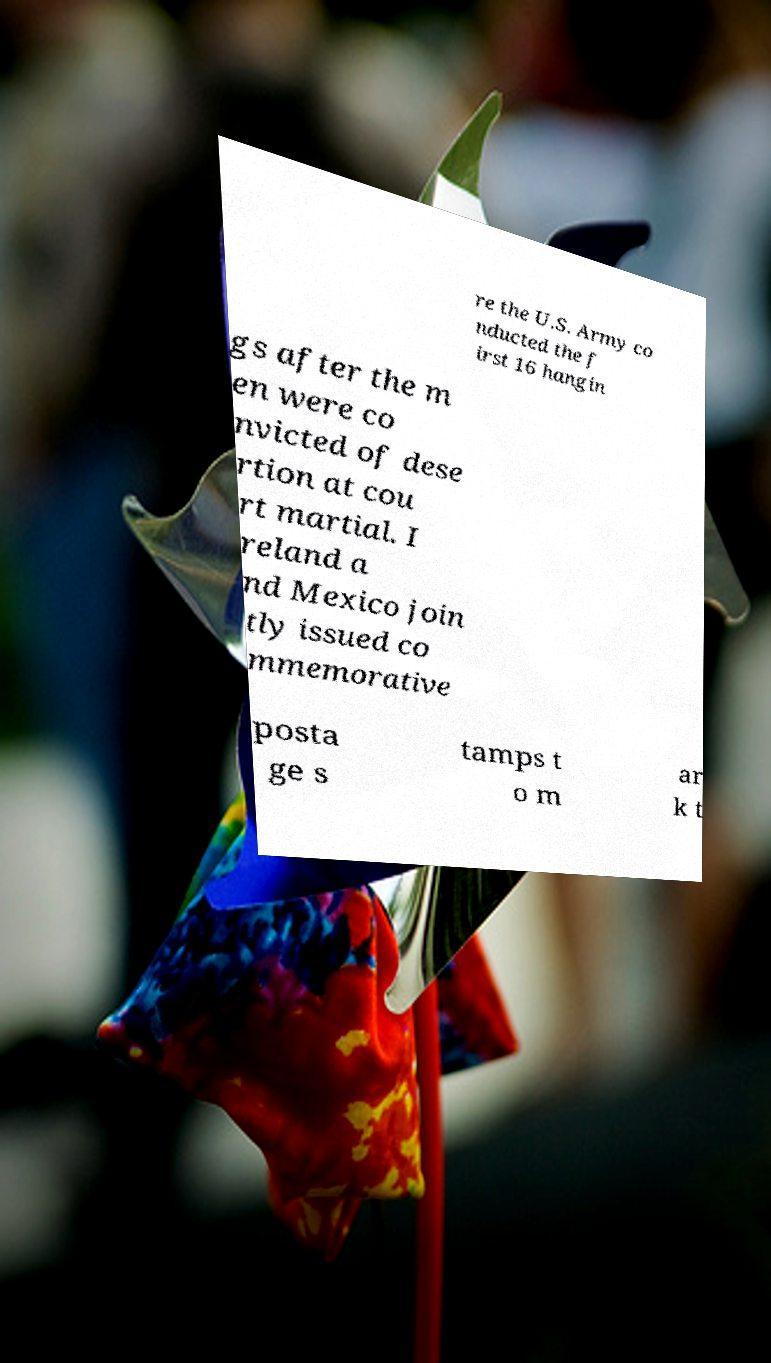For documentation purposes, I need the text within this image transcribed. Could you provide that? re the U.S. Army co nducted the f irst 16 hangin gs after the m en were co nvicted of dese rtion at cou rt martial. I reland a nd Mexico join tly issued co mmemorative posta ge s tamps t o m ar k t 